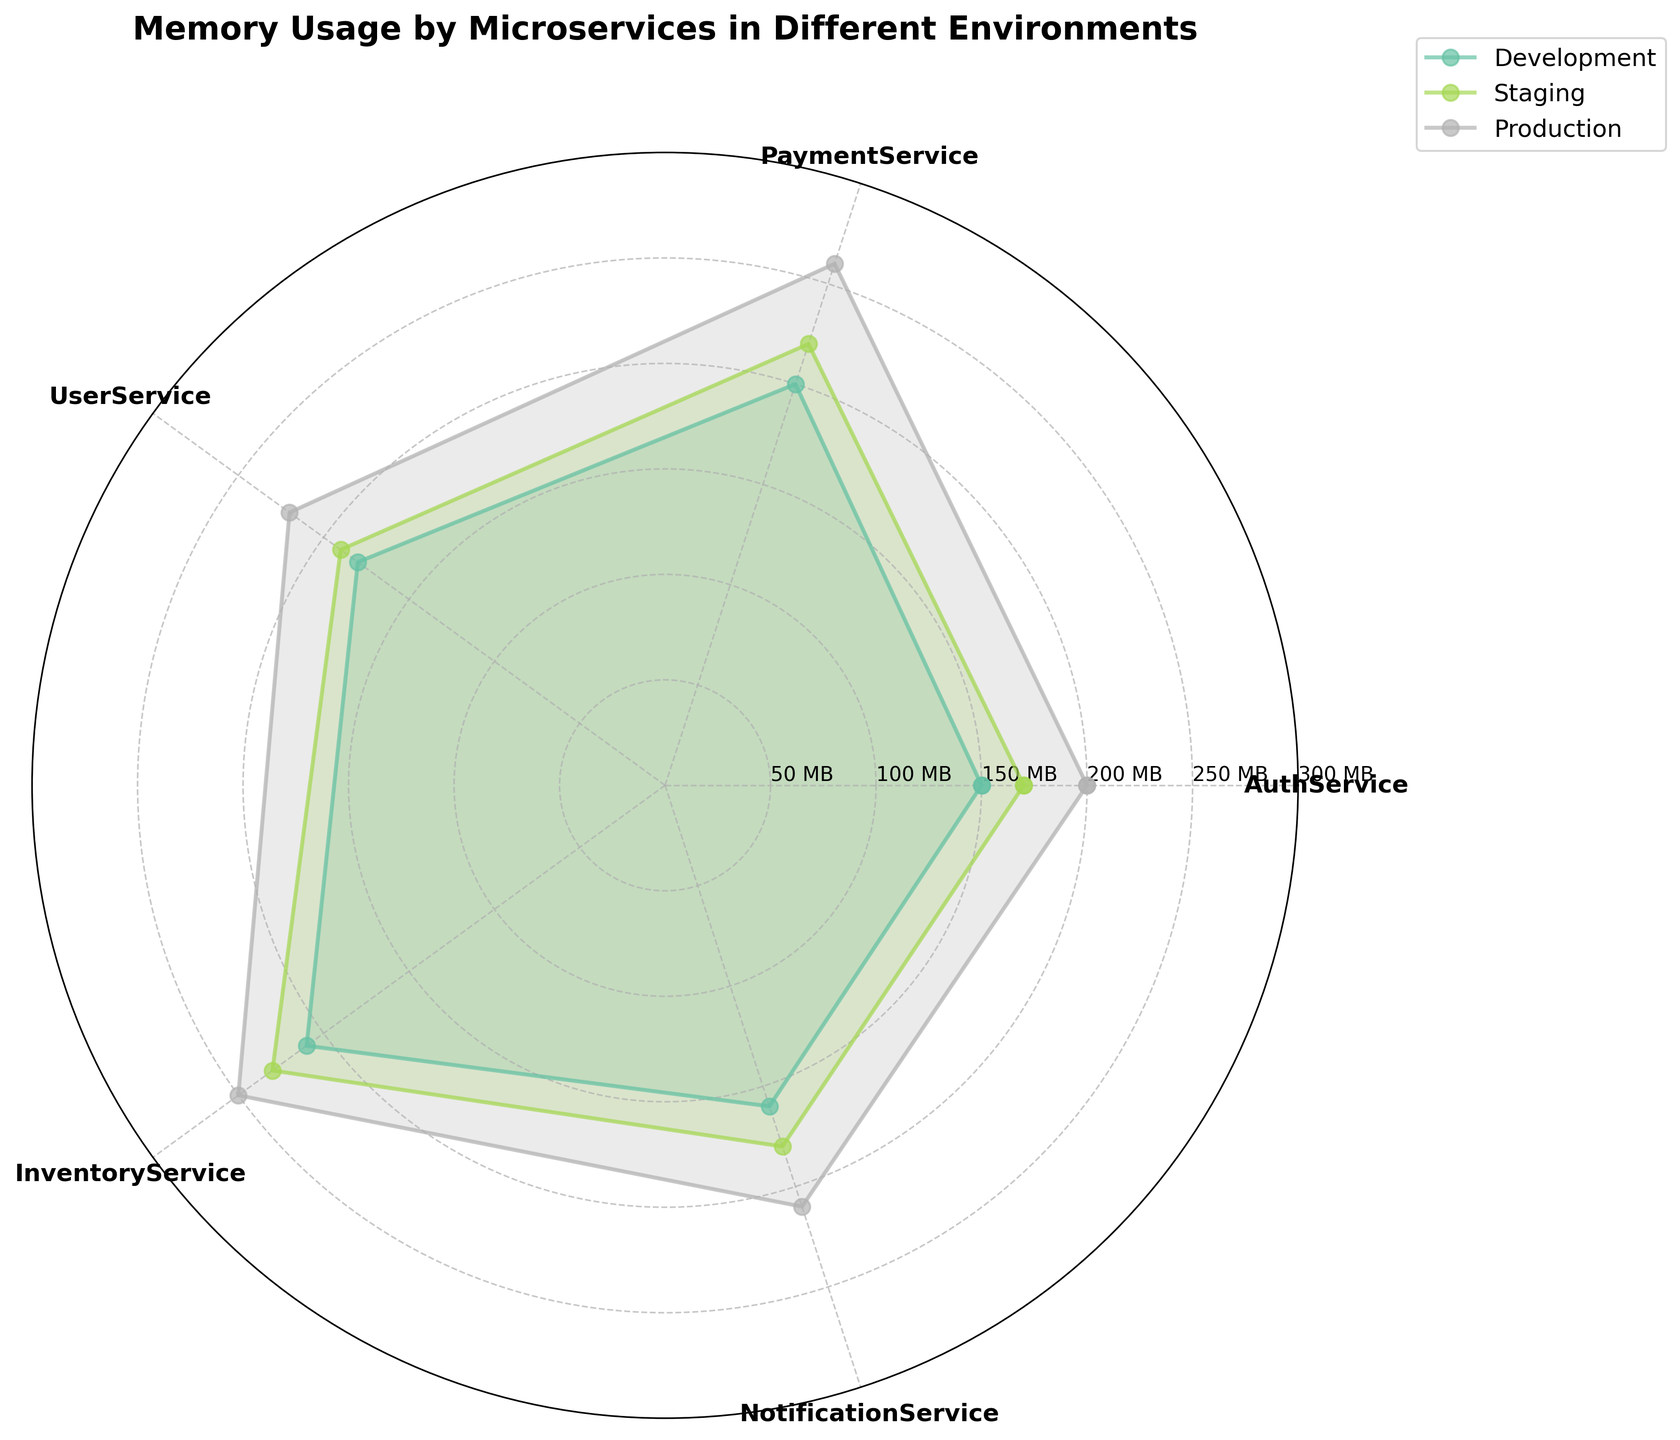What is the title of the polar area chart? The title of the chart is usually placed at the top center of the figure. It is added to give a concise description of what the chart represents. In this case, it describes the memory usage by different microservices across various environments.
Answer: Memory Usage by Microservices in Different Environments What is the memory usage of AuthService in the Production environment? Look for the data point related to AuthService on the chart, and check the section labeled "Production" for its memory usage.
Answer: 200 MB Which environment generally shows the highest memory usage across all services? By comparing the values across different environments (Development, Staging, Production) for each service, you'll notice that the Production environment consistently has the highest memory usage.
Answer: Production What is the total memory usage of PaymentService across all environments? Identify the memory usage values for PaymentService in Development, Staging, and Production environments. Sum these values together: 200 MB + 220 MB + 260 MB.
Answer: 680 MB Which service has the lowest memory usage in the Development environment? Examine the memory usage values of each service in the Development environment section. The service with the smallest value is the correct answer.
Answer: AuthService What is the average memory usage of UserService in Development and Production environments? Identify the values for UserService in the Development (180 MB) and Production (220 MB) environments and calculate the average: (180 + 220) / 2.
Answer: 200 MB Comparing the NotificationService in Staging and Production, which has higher memory usage and by how much? Identify the values for NotificationService in Staging (180 MB) and Production (210 MB) environments. Subtract the Staging value from the Production value: 210 MB - 180 MB.
Answer: Production by 30 MB Which service has the highest memory usage in the Staging environment? Examine the memory usage values of each service in the Staging environment section. The service with the highest value is the correct answer.
Answer: InventoryService How does the memory usage of InventoryService in Production compare to PaymentService in Staging? Identify the values for InventoryService in Production (250 MB) and PaymentService in Staging (220 MB), and compare the two values to determine which is higher.
Answer: InventoryService in Production What is the difference in memory usage of NotificationService between Development and Production environments? Identify the values for NotificationService in Development (160 MB) and Production (210 MB) environments. Subtract the Development value from the Production value: 210 MB - 160 MB.
Answer: 50 MB 